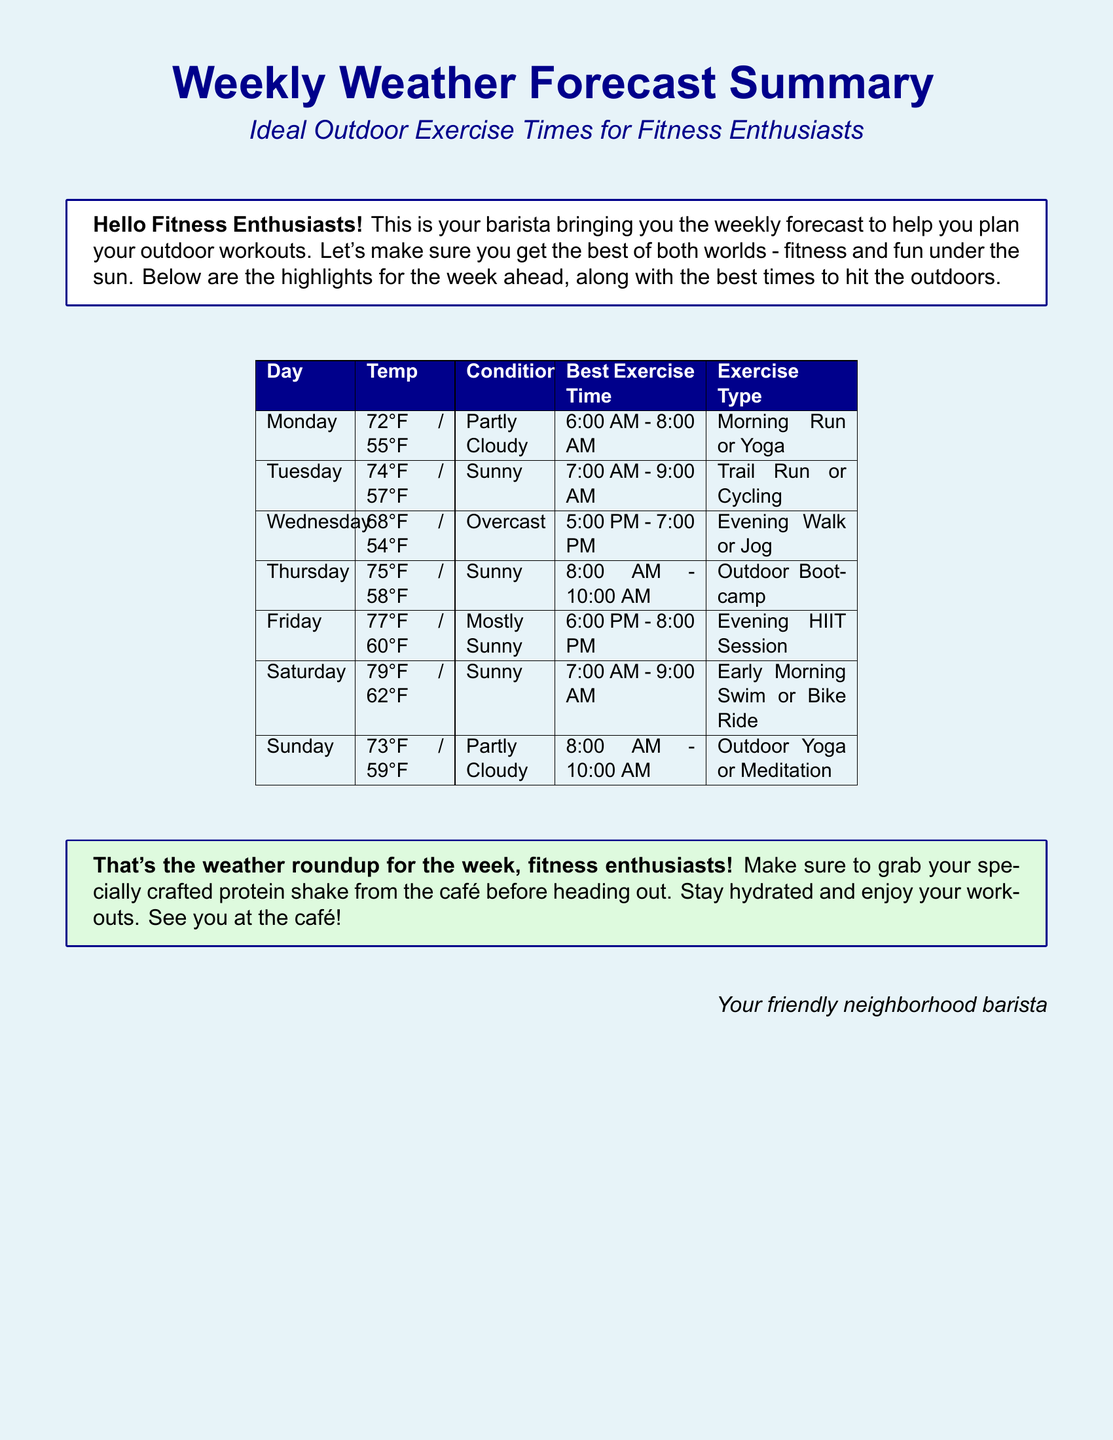What is the temperature on Tuesday? The temperature on Tuesday is provided in the document as 74°F / 57°F.
Answer: 74°F / 57°F What time is best for outdoor yoga on Sunday? The document specifies that the best exercise time for outdoor yoga on Sunday is from 8:00 AM to 10:00 AM.
Answer: 8:00 AM - 10:00 AM What type of exercise is recommended on Friday? The document lists the recommended exercise type for Friday as an Evening HIIT Session.
Answer: Evening HIIT Session Which day has the warmest temperature forecast? By comparing the temperatures listed, Saturday has the warmest forecast with 79°F / 62°F.
Answer: Saturday What are the conditions for Wednesday? The conditions for Wednesday are stated as Overcast in the document.
Answer: Overcast On which day is the ideal time for a morning run? The document indicates that Monday is ideal for a morning run during the time from 6:00 AM to 8:00 AM.
Answer: Monday How many days have sunny conditions? By checking the report, sunny conditions are indicated for Tuesday, Thursday, and Saturday, totaling three days.
Answer: Three days What should enthusiasts grab before heading out for workouts? The document advises grabbing a specially crafted protein shake from the café before heading out.
Answer: Protein shake 